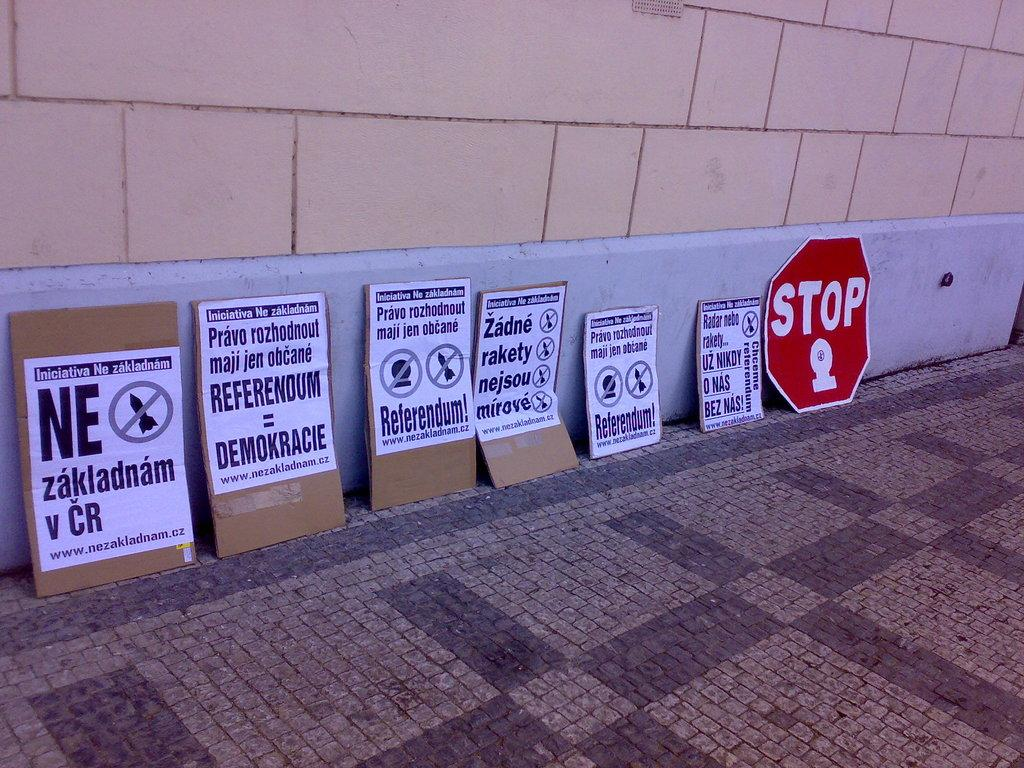Provide a one-sentence caption for the provided image. Several protest posters rest against a wall to the left of one poster that says STOP. 